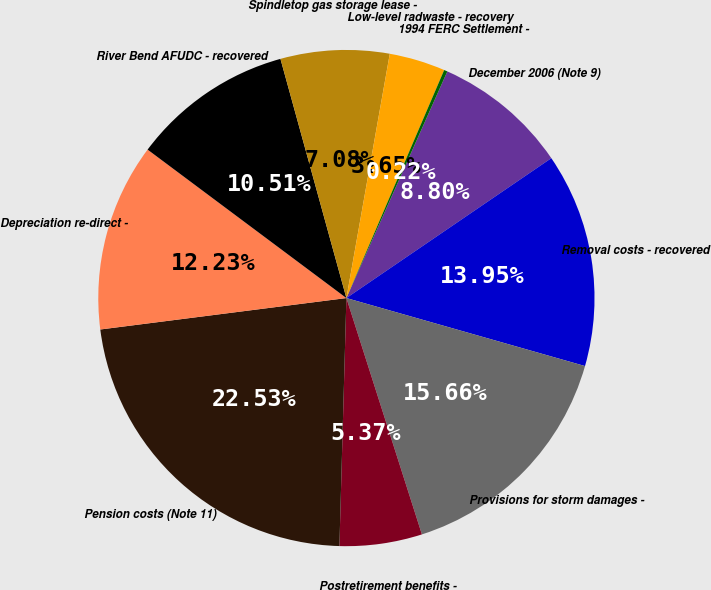<chart> <loc_0><loc_0><loc_500><loc_500><pie_chart><fcel>December 2006 (Note 9)<fcel>Removal costs - recovered<fcel>Provisions for storm damages -<fcel>Postretirement benefits -<fcel>Pension costs (Note 11)<fcel>Depreciation re-direct -<fcel>River Bend AFUDC - recovered<fcel>Spindletop gas storage lease -<fcel>Low-level radwaste - recovery<fcel>1994 FERC Settlement -<nl><fcel>8.8%<fcel>13.95%<fcel>15.66%<fcel>5.37%<fcel>22.53%<fcel>12.23%<fcel>10.51%<fcel>7.08%<fcel>3.65%<fcel>0.22%<nl></chart> 